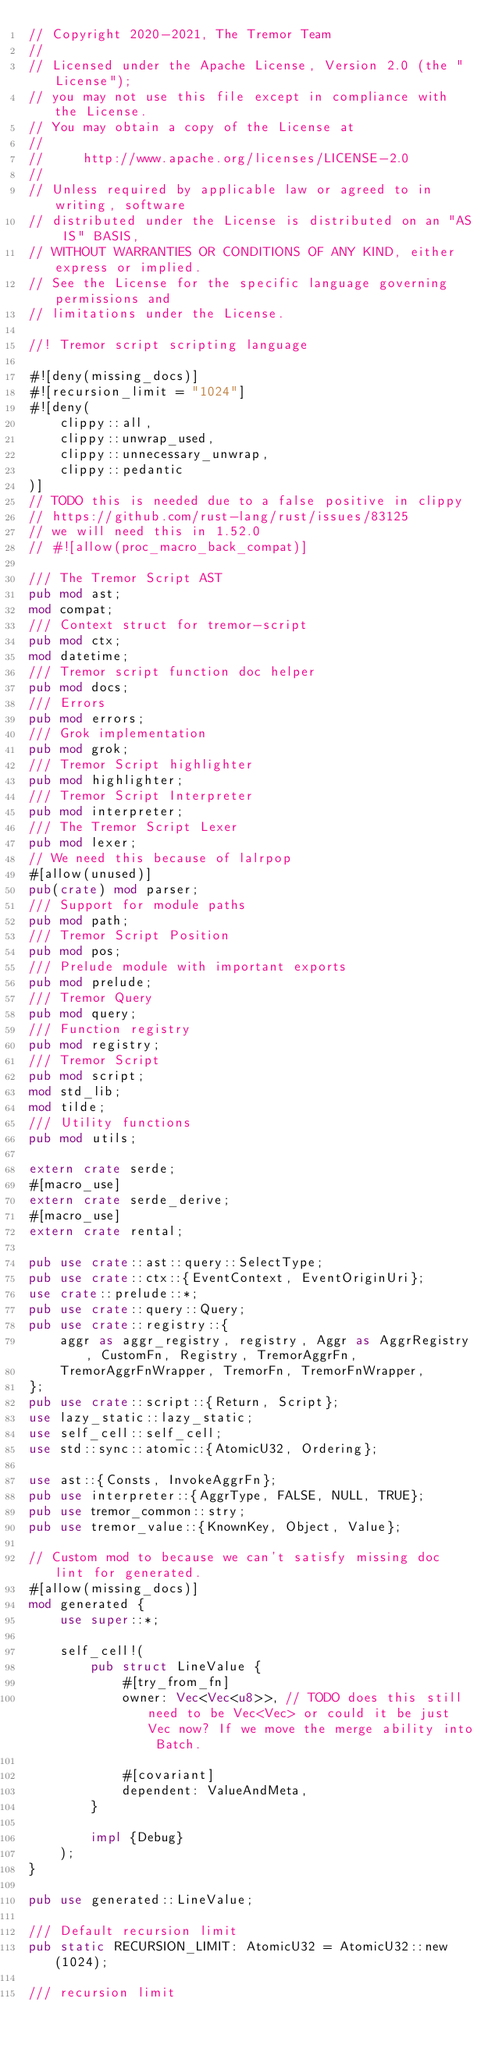Convert code to text. <code><loc_0><loc_0><loc_500><loc_500><_Rust_>// Copyright 2020-2021, The Tremor Team
//
// Licensed under the Apache License, Version 2.0 (the "License");
// you may not use this file except in compliance with the License.
// You may obtain a copy of the License at
//
//     http://www.apache.org/licenses/LICENSE-2.0
//
// Unless required by applicable law or agreed to in writing, software
// distributed under the License is distributed on an "AS IS" BASIS,
// WITHOUT WARRANTIES OR CONDITIONS OF ANY KIND, either express or implied.
// See the License for the specific language governing permissions and
// limitations under the License.

//! Tremor script scripting language

#![deny(missing_docs)]
#![recursion_limit = "1024"]
#![deny(
    clippy::all,
    clippy::unwrap_used,
    clippy::unnecessary_unwrap,
    clippy::pedantic
)]
// TODO this is needed due to a false positive in clippy
// https://github.com/rust-lang/rust/issues/83125
// we will need this in 1.52.0
// #![allow(proc_macro_back_compat)]

/// The Tremor Script AST
pub mod ast;
mod compat;
/// Context struct for tremor-script
pub mod ctx;
mod datetime;
/// Tremor script function doc helper
pub mod docs;
/// Errors
pub mod errors;
/// Grok implementation
pub mod grok;
/// Tremor Script highlighter
pub mod highlighter;
/// Tremor Script Interpreter
pub mod interpreter;
/// The Tremor Script Lexer
pub mod lexer;
// We need this because of lalrpop
#[allow(unused)]
pub(crate) mod parser;
/// Support for module paths
pub mod path;
/// Tremor Script Position
pub mod pos;
/// Prelude module with important exports
pub mod prelude;
/// Tremor Query
pub mod query;
/// Function registry
pub mod registry;
/// Tremor Script
pub mod script;
mod std_lib;
mod tilde;
/// Utility functions
pub mod utils;

extern crate serde;
#[macro_use]
extern crate serde_derive;
#[macro_use]
extern crate rental;

pub use crate::ast::query::SelectType;
pub use crate::ctx::{EventContext, EventOriginUri};
use crate::prelude::*;
pub use crate::query::Query;
pub use crate::registry::{
    aggr as aggr_registry, registry, Aggr as AggrRegistry, CustomFn, Registry, TremorAggrFn,
    TremorAggrFnWrapper, TremorFn, TremorFnWrapper,
};
pub use crate::script::{Return, Script};
use lazy_static::lazy_static;
use self_cell::self_cell;
use std::sync::atomic::{AtomicU32, Ordering};

use ast::{Consts, InvokeAggrFn};
pub use interpreter::{AggrType, FALSE, NULL, TRUE};
pub use tremor_common::stry;
pub use tremor_value::{KnownKey, Object, Value};

// Custom mod to because we can't satisfy missing doc lint for generated.
#[allow(missing_docs)]
mod generated {
    use super::*;

    self_cell!(
        pub struct LineValue {
            #[try_from_fn]
            owner: Vec<Vec<u8>>, // TODO does this still need to be Vec<Vec> or could it be just Vec now? If we move the merge ability into Batch.

            #[covariant]
            dependent: ValueAndMeta,
        }

        impl {Debug}
    );
}

pub use generated::LineValue;

/// Default recursion limit
pub static RECURSION_LIMIT: AtomicU32 = AtomicU32::new(1024);

/// recursion limit</code> 